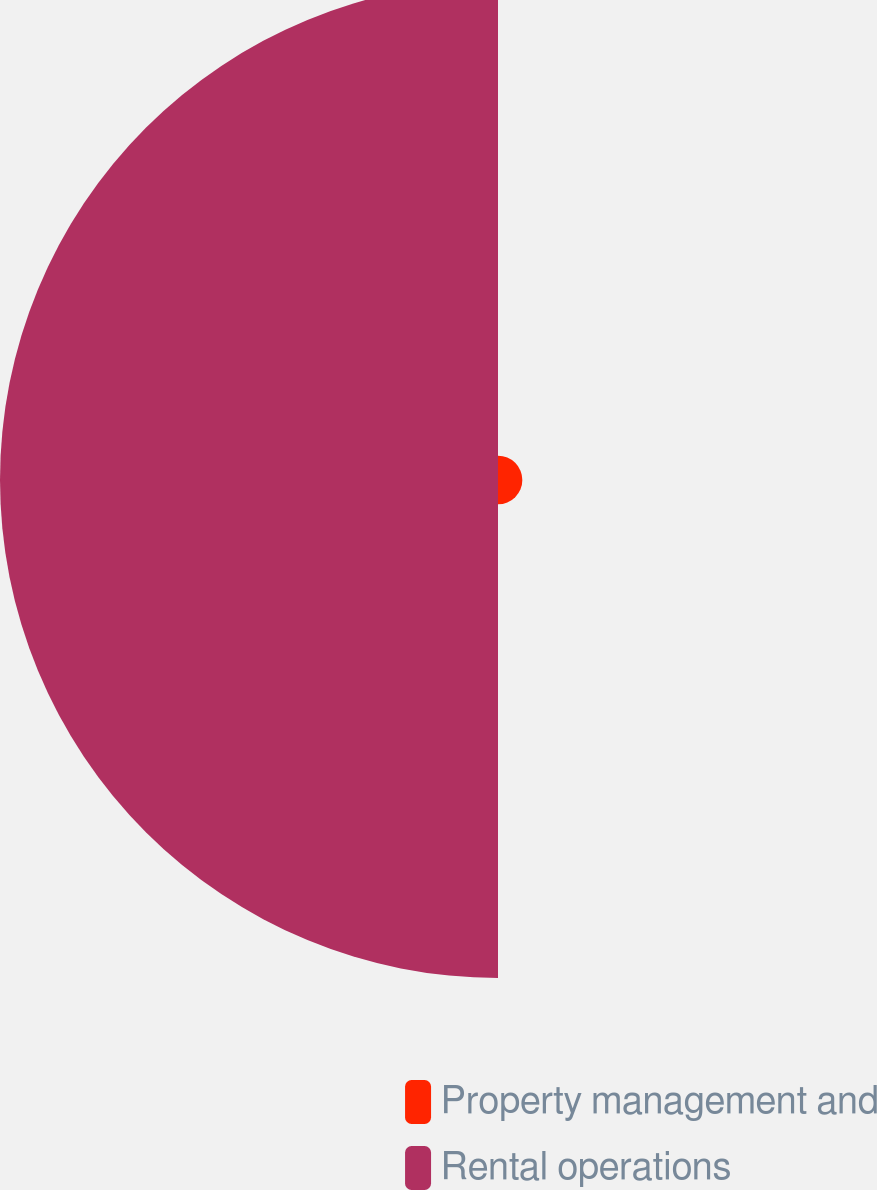Convert chart to OTSL. <chart><loc_0><loc_0><loc_500><loc_500><pie_chart><fcel>Property management and<fcel>Rental operations<nl><fcel>4.66%<fcel>95.34%<nl></chart> 